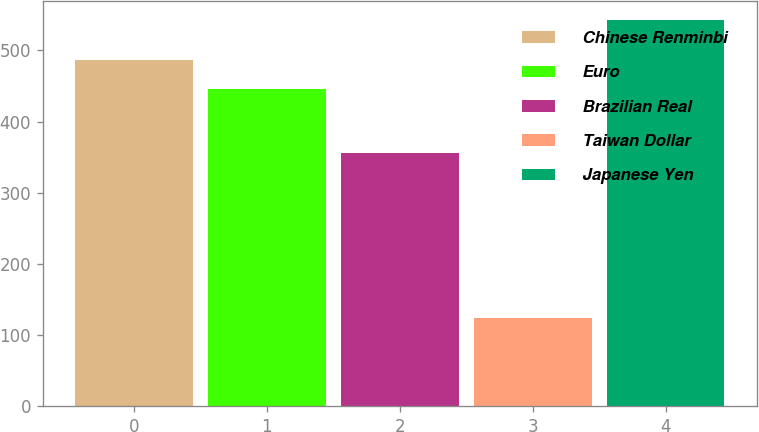Convert chart to OTSL. <chart><loc_0><loc_0><loc_500><loc_500><bar_chart><fcel>Chinese Renminbi<fcel>Euro<fcel>Brazilian Real<fcel>Taiwan Dollar<fcel>Japanese Yen<nl><fcel>486.8<fcel>445<fcel>356<fcel>124<fcel>542<nl></chart> 